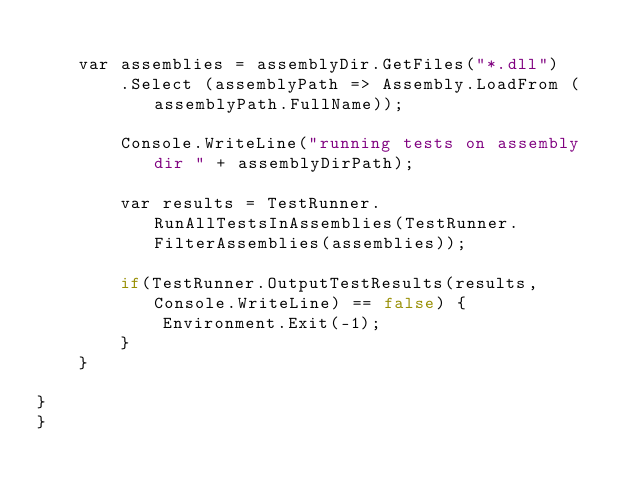<code> <loc_0><loc_0><loc_500><loc_500><_C#_>
		var assemblies = assemblyDir.GetFiles("*.dll")
				.Select (assemblyPath => Assembly.LoadFrom (assemblyPath.FullName));
			
        Console.WriteLine("running tests on assembly dir " + assemblyDirPath);

        var results = TestRunner.RunAllTestsInAssemblies(TestRunner.FilterAssemblies(assemblies));

        if(TestRunner.OutputTestResults(results, Console.WriteLine) == false) {
            Environment.Exit(-1);
        }
    }

}
}</code> 